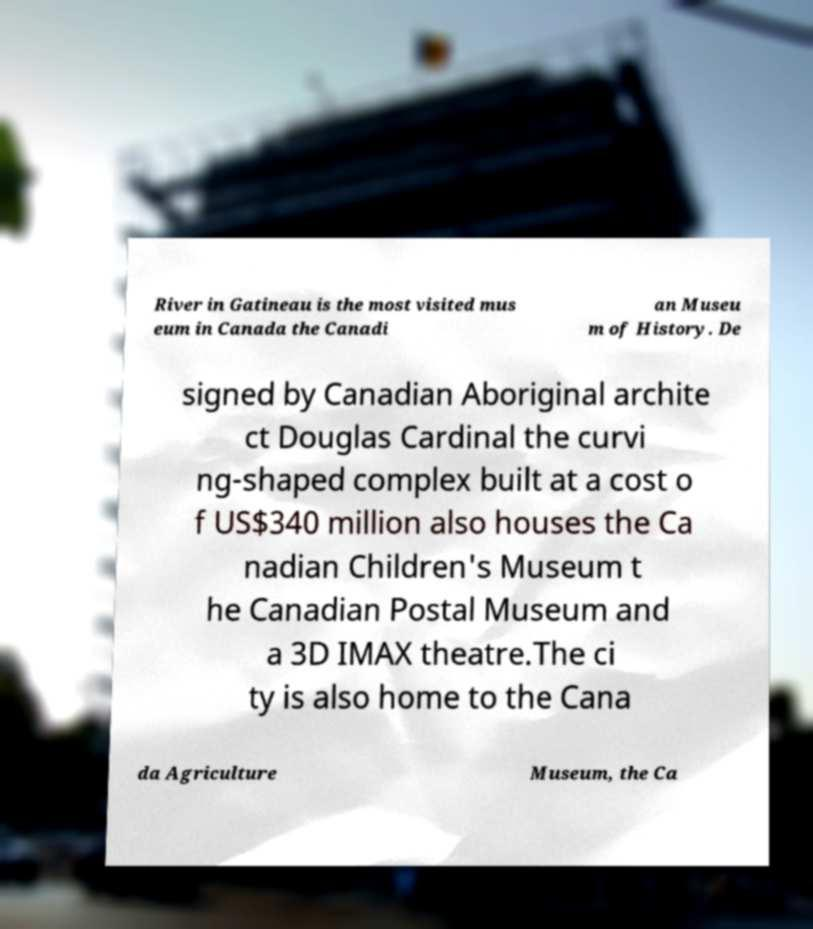I need the written content from this picture converted into text. Can you do that? River in Gatineau is the most visited mus eum in Canada the Canadi an Museu m of History. De signed by Canadian Aboriginal archite ct Douglas Cardinal the curvi ng-shaped complex built at a cost o f US$340 million also houses the Ca nadian Children's Museum t he Canadian Postal Museum and a 3D IMAX theatre.The ci ty is also home to the Cana da Agriculture Museum, the Ca 